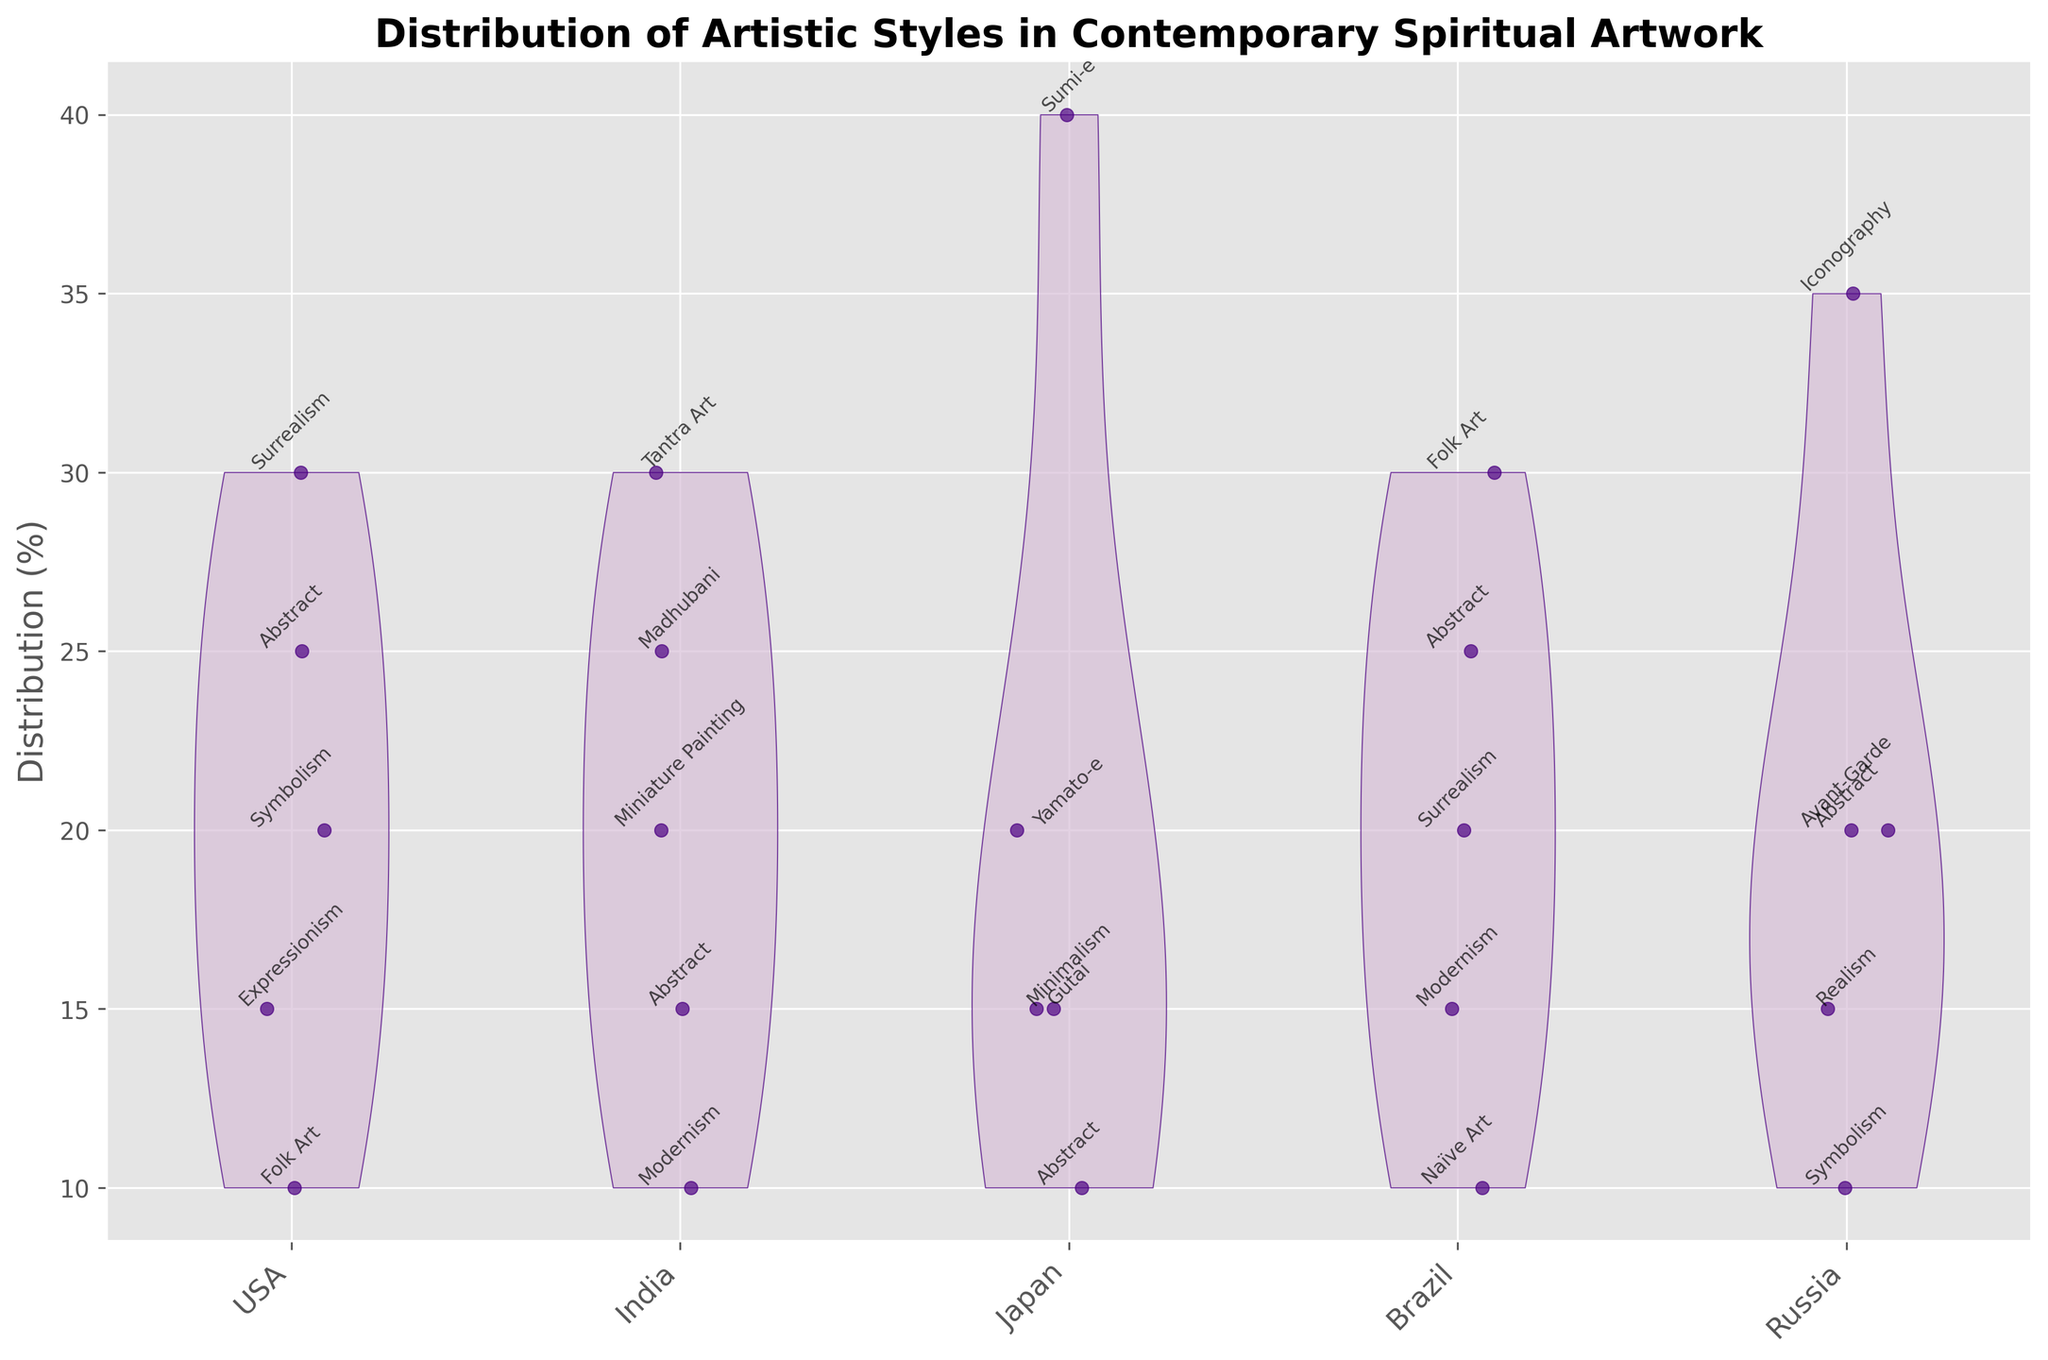What is the title of the chart? The title is located at the top of the chart, indicating the main subject of the violin plot.
Answer: Distribution of Artistic Styles in Contemporary Spiritual Artwork What axis shows the countries being analyzed? The X-axis of the chart displays the countries being analyzed, which are listed at the bottom of the chart.
Answer: X-axis Which country has the highest distribution in Sumi-e? By observing the chart, we can see that Japan has the highest distribution of Sumi-e, which reaches up to 40%.
Answer: Japan Among the artistic styles in the USA, which one appears to have the smallest distribution? By examining the violin plot for the USA, Folk Art shows the smallest distribution, which is around 10%.
Answer: Folk Art What is the distribution range of Abstract artworks in India? In India, the distribution for Abstract artworks can be viewed between the range of 10% to 15% as indicated on the Y-axis.
Answer: 10% to 15% Compare the distribution of Surrealism between the USA and Brazil. Which country has a higher percentage? By comparing the two violins for Surrealism in the USA and Brazil, it's clear that the USA has a higher distribution at 30% while Brazil is at 20%.
Answer: USA What is the distribution of Iconography in Russia? The chart shows the distribution of Iconography in Russia reaching up to 35%, as indicated on the Y-axis and the text label.
Answer: 35% Which artistic style has the broadest range of distribution in Japan? Observing all the artistic styles under Japan, Sumi-e shows the broadest range since it spans from the baseline to the highest point at 40%.
Answer: Sumi-e What is the combined distribution percentage of Symbolism and Abstract in the USA? Add the distribution values of Symbolism (20%) and Abstract (25%) in the USA. 20% + 25% = 45%.
Answer: 45% Which country has the most diverse range of artistic styles depicted in the violin plot? By examining the total number of different artistic styles for each country, the USA has the most diverse range with styles like Abstract, Symbolism, Surrealism, Expressionism, and Folk Art.
Answer: USA 